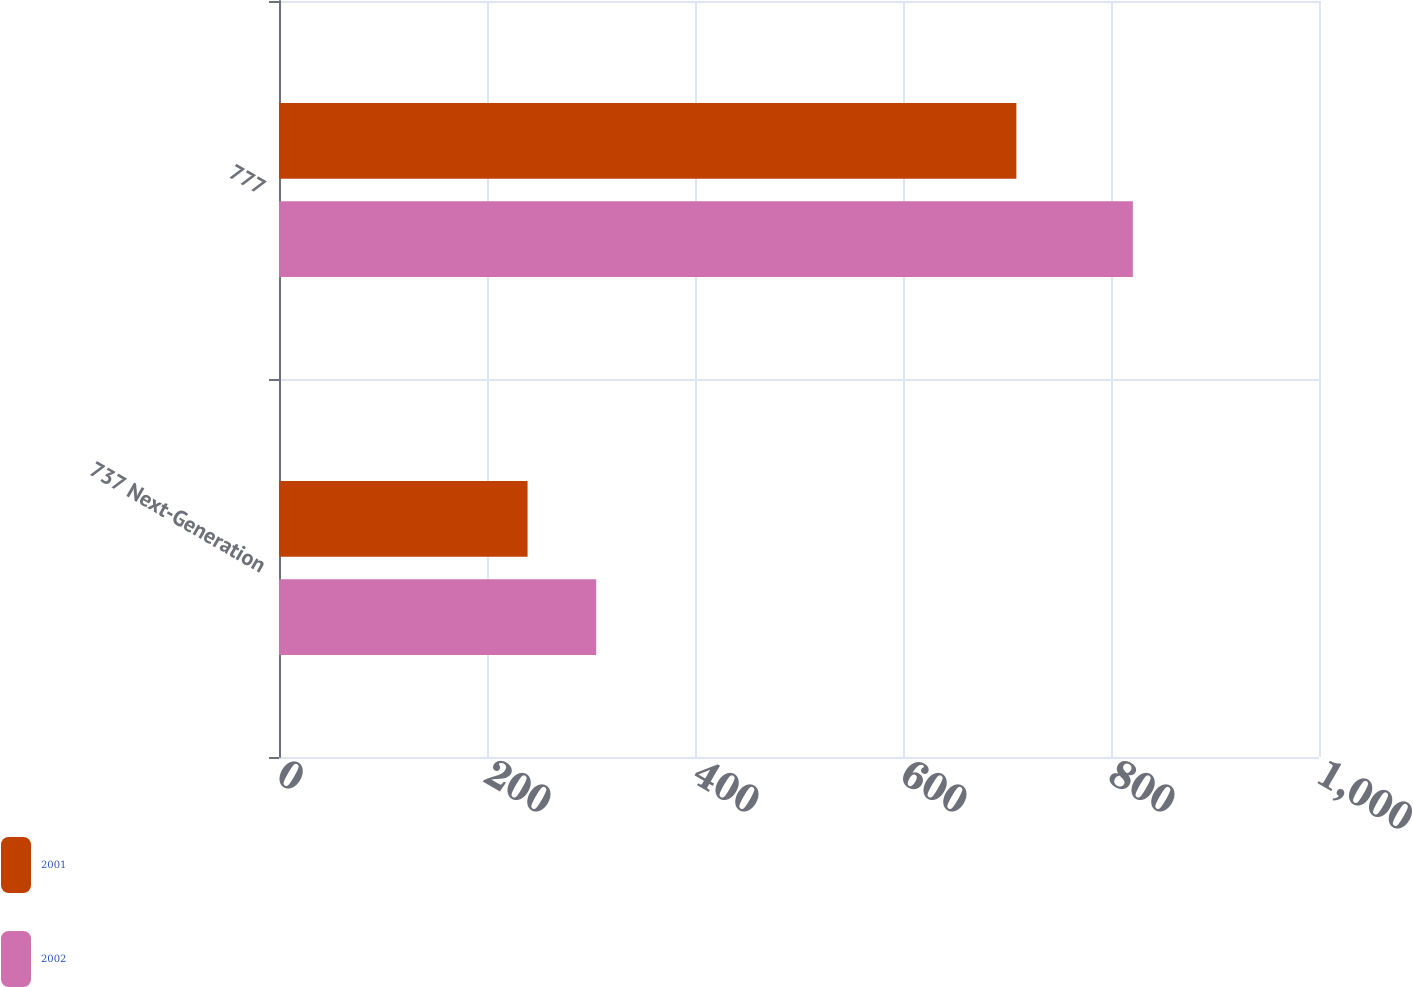Convert chart. <chart><loc_0><loc_0><loc_500><loc_500><stacked_bar_chart><ecel><fcel>737 Next-Generation<fcel>777<nl><fcel>2001<fcel>239<fcel>709<nl><fcel>2002<fcel>305<fcel>821<nl></chart> 